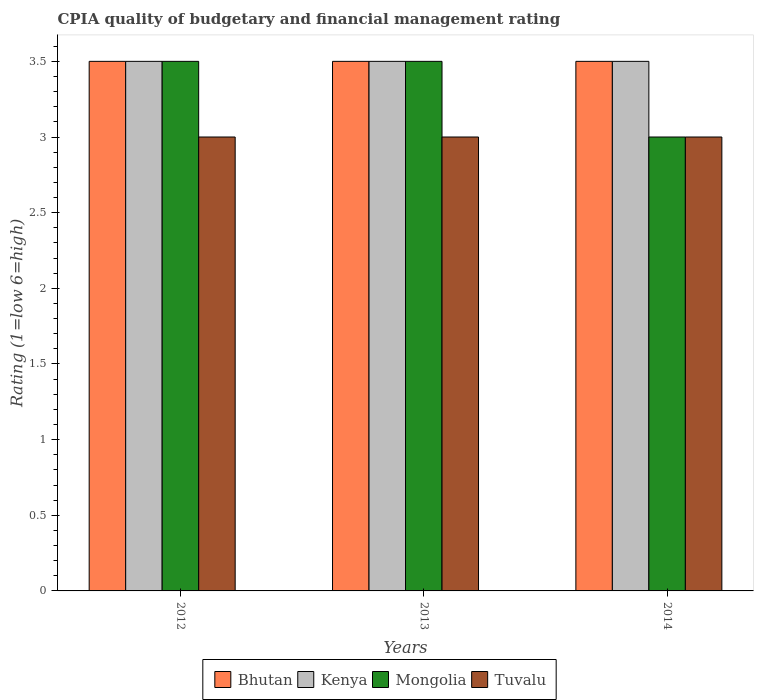Are the number of bars per tick equal to the number of legend labels?
Offer a very short reply. Yes. Are the number of bars on each tick of the X-axis equal?
Provide a succinct answer. Yes. In how many cases, is the number of bars for a given year not equal to the number of legend labels?
Make the answer very short. 0. What is the CPIA rating in Kenya in 2012?
Keep it short and to the point. 3.5. Across all years, what is the minimum CPIA rating in Mongolia?
Make the answer very short. 3. In which year was the CPIA rating in Mongolia maximum?
Your answer should be compact. 2012. In which year was the CPIA rating in Mongolia minimum?
Keep it short and to the point. 2014. What is the average CPIA rating in Mongolia per year?
Offer a very short reply. 3.33. What is the ratio of the CPIA rating in Mongolia in 2012 to that in 2014?
Your response must be concise. 1.17. Is the difference between the CPIA rating in Mongolia in 2012 and 2014 greater than the difference between the CPIA rating in Kenya in 2012 and 2014?
Offer a very short reply. Yes. What is the difference between the highest and the lowest CPIA rating in Mongolia?
Offer a very short reply. 0.5. Is it the case that in every year, the sum of the CPIA rating in Tuvalu and CPIA rating in Bhutan is greater than the sum of CPIA rating in Kenya and CPIA rating in Mongolia?
Provide a short and direct response. No. What does the 3rd bar from the left in 2012 represents?
Your answer should be very brief. Mongolia. What does the 4th bar from the right in 2012 represents?
Keep it short and to the point. Bhutan. Is it the case that in every year, the sum of the CPIA rating in Mongolia and CPIA rating in Kenya is greater than the CPIA rating in Tuvalu?
Provide a succinct answer. Yes. How many bars are there?
Give a very brief answer. 12. Are all the bars in the graph horizontal?
Provide a succinct answer. No. How many years are there in the graph?
Your response must be concise. 3. Are the values on the major ticks of Y-axis written in scientific E-notation?
Your answer should be compact. No. Does the graph contain any zero values?
Make the answer very short. No. How many legend labels are there?
Keep it short and to the point. 4. What is the title of the graph?
Make the answer very short. CPIA quality of budgetary and financial management rating. Does "Northern Mariana Islands" appear as one of the legend labels in the graph?
Ensure brevity in your answer.  No. What is the label or title of the X-axis?
Provide a short and direct response. Years. What is the Rating (1=low 6=high) of Mongolia in 2012?
Offer a terse response. 3.5. What is the Rating (1=low 6=high) of Kenya in 2013?
Give a very brief answer. 3.5. What is the Rating (1=low 6=high) of Tuvalu in 2013?
Provide a succinct answer. 3. What is the Rating (1=low 6=high) in Bhutan in 2014?
Provide a succinct answer. 3.5. What is the Rating (1=low 6=high) of Tuvalu in 2014?
Offer a terse response. 3. Across all years, what is the maximum Rating (1=low 6=high) in Bhutan?
Provide a succinct answer. 3.5. Across all years, what is the maximum Rating (1=low 6=high) in Tuvalu?
Offer a very short reply. 3. Across all years, what is the minimum Rating (1=low 6=high) in Mongolia?
Make the answer very short. 3. Across all years, what is the minimum Rating (1=low 6=high) in Tuvalu?
Keep it short and to the point. 3. What is the total Rating (1=low 6=high) of Bhutan in the graph?
Keep it short and to the point. 10.5. What is the total Rating (1=low 6=high) in Kenya in the graph?
Offer a terse response. 10.5. What is the total Rating (1=low 6=high) of Mongolia in the graph?
Your response must be concise. 10. What is the difference between the Rating (1=low 6=high) of Kenya in 2012 and that in 2013?
Give a very brief answer. 0. What is the difference between the Rating (1=low 6=high) of Mongolia in 2012 and that in 2013?
Offer a very short reply. 0. What is the difference between the Rating (1=low 6=high) of Bhutan in 2012 and that in 2014?
Make the answer very short. 0. What is the difference between the Rating (1=low 6=high) in Bhutan in 2012 and the Rating (1=low 6=high) in Kenya in 2013?
Ensure brevity in your answer.  0. What is the difference between the Rating (1=low 6=high) in Bhutan in 2012 and the Rating (1=low 6=high) in Mongolia in 2013?
Your response must be concise. 0. What is the difference between the Rating (1=low 6=high) of Bhutan in 2012 and the Rating (1=low 6=high) of Tuvalu in 2013?
Ensure brevity in your answer.  0.5. What is the difference between the Rating (1=low 6=high) of Kenya in 2012 and the Rating (1=low 6=high) of Mongolia in 2013?
Provide a short and direct response. 0. What is the difference between the Rating (1=low 6=high) in Kenya in 2012 and the Rating (1=low 6=high) in Tuvalu in 2013?
Your answer should be very brief. 0.5. What is the difference between the Rating (1=low 6=high) in Mongolia in 2012 and the Rating (1=low 6=high) in Tuvalu in 2013?
Offer a terse response. 0.5. What is the difference between the Rating (1=low 6=high) of Bhutan in 2012 and the Rating (1=low 6=high) of Kenya in 2014?
Your answer should be very brief. 0. What is the difference between the Rating (1=low 6=high) in Bhutan in 2012 and the Rating (1=low 6=high) in Mongolia in 2014?
Offer a terse response. 0.5. What is the difference between the Rating (1=low 6=high) of Kenya in 2012 and the Rating (1=low 6=high) of Mongolia in 2014?
Offer a very short reply. 0.5. What is the difference between the Rating (1=low 6=high) in Kenya in 2012 and the Rating (1=low 6=high) in Tuvalu in 2014?
Offer a very short reply. 0.5. What is the difference between the Rating (1=low 6=high) of Bhutan in 2013 and the Rating (1=low 6=high) of Mongolia in 2014?
Offer a very short reply. 0.5. What is the difference between the Rating (1=low 6=high) in Kenya in 2013 and the Rating (1=low 6=high) in Mongolia in 2014?
Provide a short and direct response. 0.5. What is the difference between the Rating (1=low 6=high) of Mongolia in 2013 and the Rating (1=low 6=high) of Tuvalu in 2014?
Provide a succinct answer. 0.5. What is the average Rating (1=low 6=high) in Kenya per year?
Offer a terse response. 3.5. What is the average Rating (1=low 6=high) in Mongolia per year?
Your answer should be compact. 3.33. In the year 2012, what is the difference between the Rating (1=low 6=high) of Bhutan and Rating (1=low 6=high) of Kenya?
Provide a short and direct response. 0. In the year 2012, what is the difference between the Rating (1=low 6=high) of Kenya and Rating (1=low 6=high) of Mongolia?
Ensure brevity in your answer.  0. In the year 2012, what is the difference between the Rating (1=low 6=high) of Kenya and Rating (1=low 6=high) of Tuvalu?
Give a very brief answer. 0.5. In the year 2012, what is the difference between the Rating (1=low 6=high) of Mongolia and Rating (1=low 6=high) of Tuvalu?
Give a very brief answer. 0.5. In the year 2013, what is the difference between the Rating (1=low 6=high) of Bhutan and Rating (1=low 6=high) of Kenya?
Keep it short and to the point. 0. In the year 2013, what is the difference between the Rating (1=low 6=high) in Kenya and Rating (1=low 6=high) in Mongolia?
Offer a very short reply. 0. In the year 2013, what is the difference between the Rating (1=low 6=high) in Mongolia and Rating (1=low 6=high) in Tuvalu?
Keep it short and to the point. 0.5. In the year 2014, what is the difference between the Rating (1=low 6=high) of Bhutan and Rating (1=low 6=high) of Kenya?
Provide a succinct answer. 0. In the year 2014, what is the difference between the Rating (1=low 6=high) in Bhutan and Rating (1=low 6=high) in Mongolia?
Ensure brevity in your answer.  0.5. In the year 2014, what is the difference between the Rating (1=low 6=high) in Bhutan and Rating (1=low 6=high) in Tuvalu?
Give a very brief answer. 0.5. In the year 2014, what is the difference between the Rating (1=low 6=high) in Mongolia and Rating (1=low 6=high) in Tuvalu?
Offer a terse response. 0. What is the ratio of the Rating (1=low 6=high) in Bhutan in 2012 to that in 2013?
Your response must be concise. 1. What is the ratio of the Rating (1=low 6=high) of Kenya in 2012 to that in 2013?
Ensure brevity in your answer.  1. What is the ratio of the Rating (1=low 6=high) of Tuvalu in 2012 to that in 2013?
Provide a succinct answer. 1. What is the ratio of the Rating (1=low 6=high) of Kenya in 2012 to that in 2014?
Ensure brevity in your answer.  1. What is the ratio of the Rating (1=low 6=high) in Mongolia in 2012 to that in 2014?
Your answer should be compact. 1.17. What is the ratio of the Rating (1=low 6=high) of Tuvalu in 2012 to that in 2014?
Provide a succinct answer. 1. What is the ratio of the Rating (1=low 6=high) in Kenya in 2013 to that in 2014?
Ensure brevity in your answer.  1. What is the difference between the highest and the second highest Rating (1=low 6=high) of Bhutan?
Ensure brevity in your answer.  0. What is the difference between the highest and the second highest Rating (1=low 6=high) of Mongolia?
Provide a succinct answer. 0. What is the difference between the highest and the second highest Rating (1=low 6=high) in Tuvalu?
Make the answer very short. 0. What is the difference between the highest and the lowest Rating (1=low 6=high) in Bhutan?
Provide a succinct answer. 0. What is the difference between the highest and the lowest Rating (1=low 6=high) in Kenya?
Offer a terse response. 0. What is the difference between the highest and the lowest Rating (1=low 6=high) in Mongolia?
Offer a terse response. 0.5. What is the difference between the highest and the lowest Rating (1=low 6=high) in Tuvalu?
Your answer should be compact. 0. 